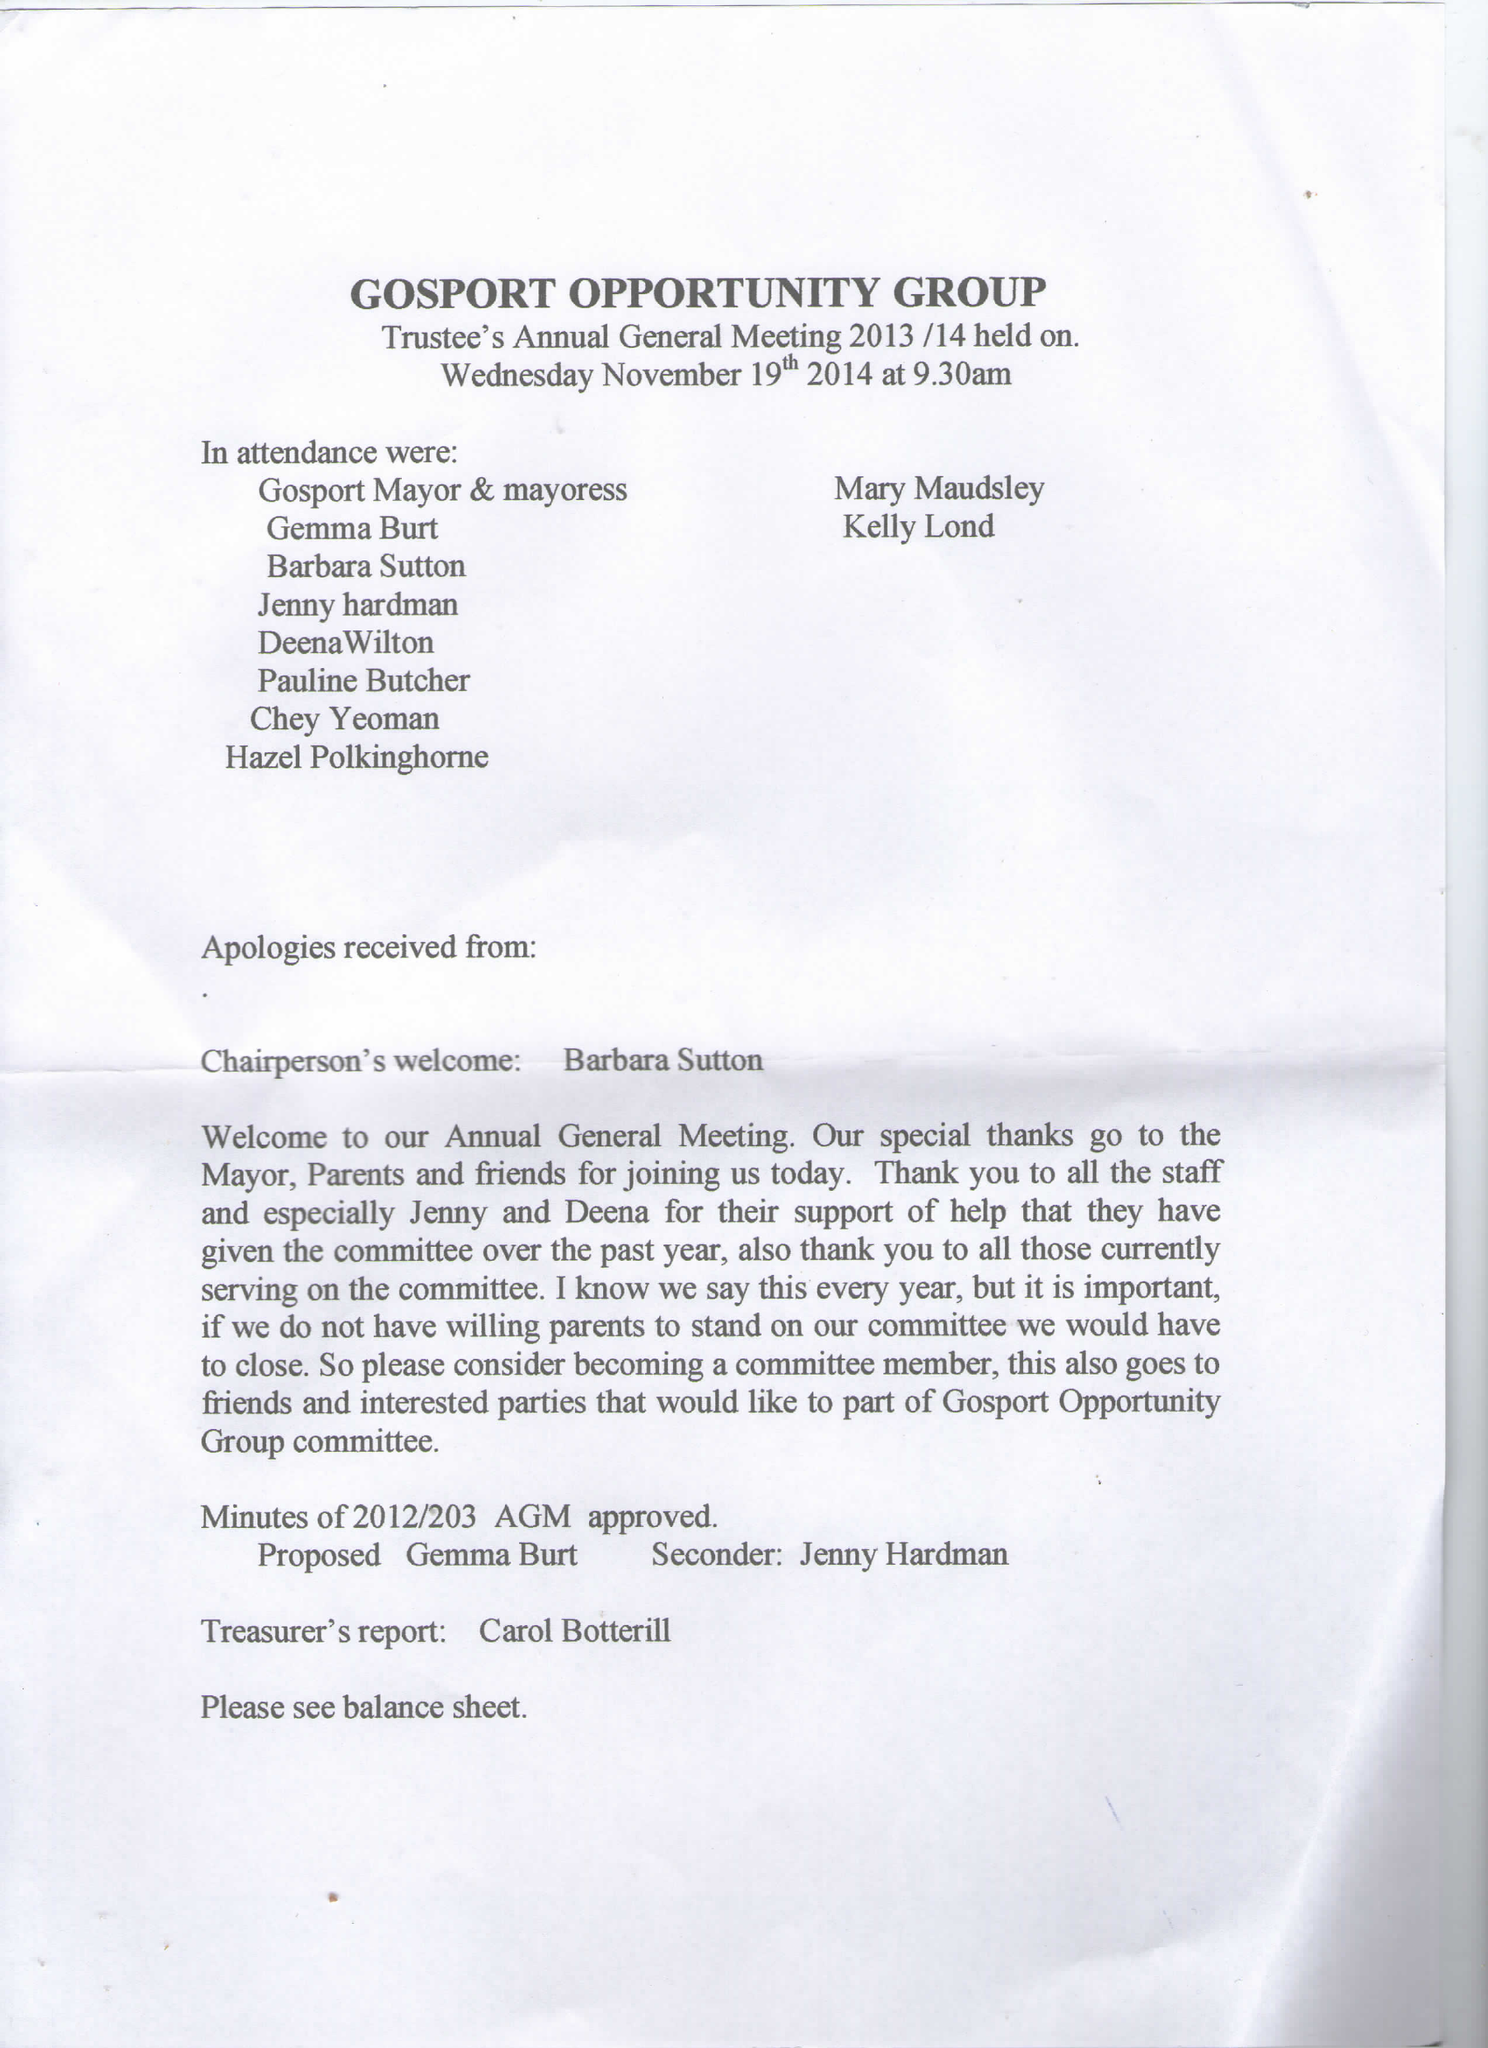What is the value for the income_annually_in_british_pounds?
Answer the question using a single word or phrase. 81373.47 